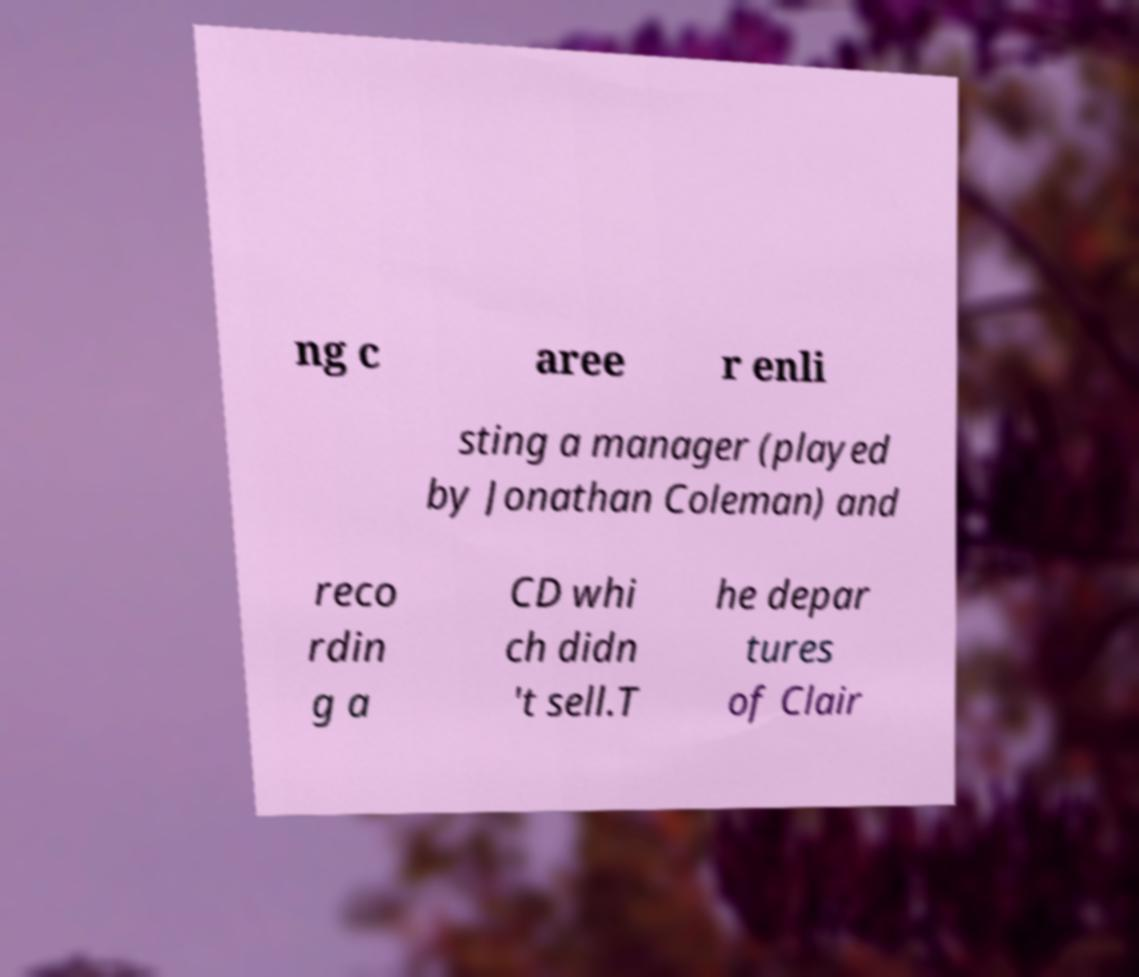Can you read and provide the text displayed in the image?This photo seems to have some interesting text. Can you extract and type it out for me? ng c aree r enli sting a manager (played by Jonathan Coleman) and reco rdin g a CD whi ch didn 't sell.T he depar tures of Clair 